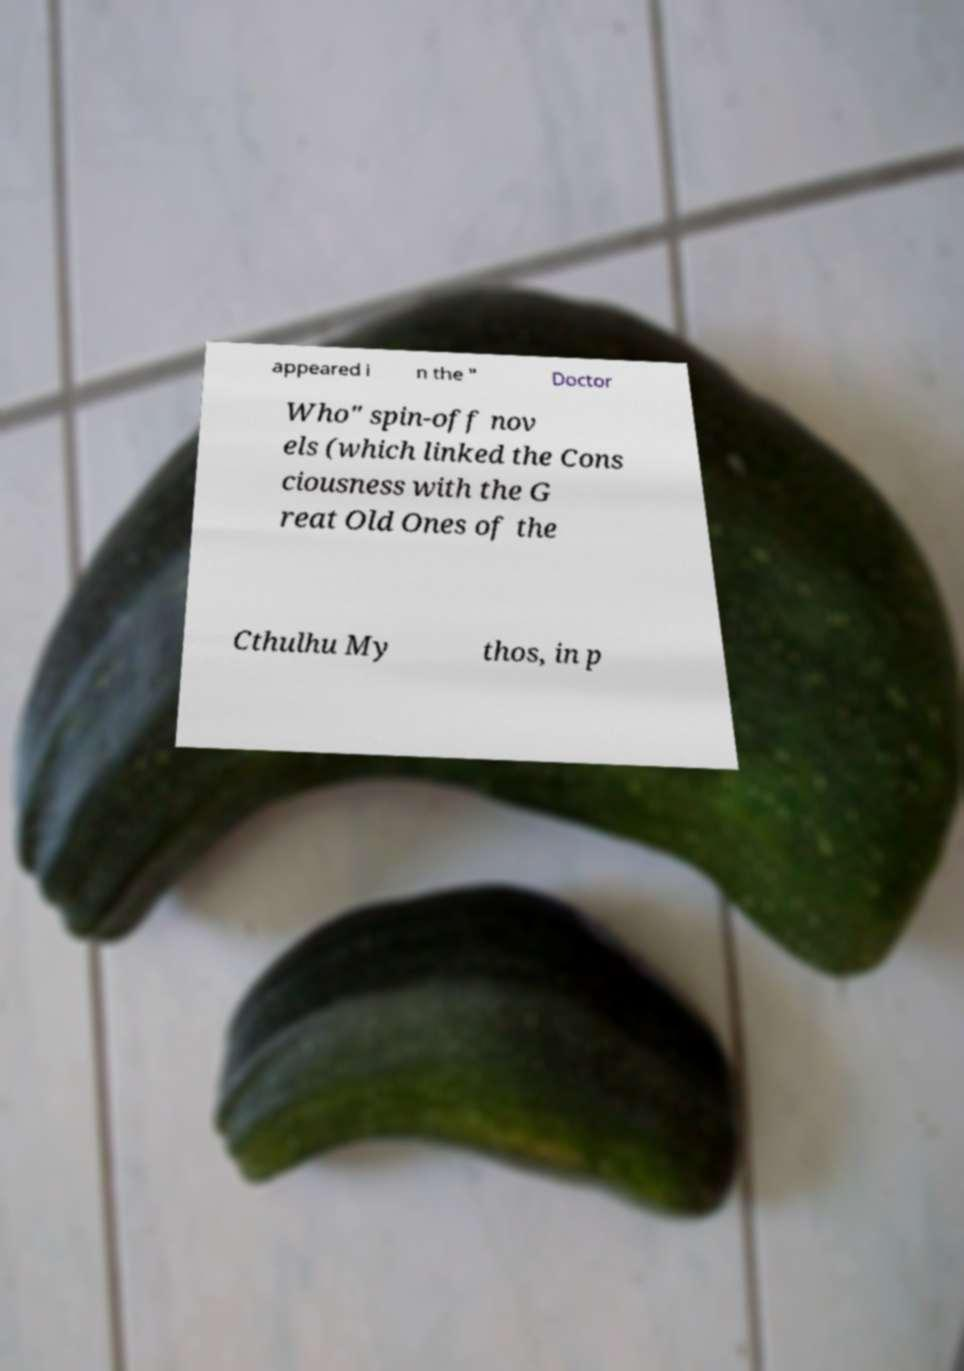Please identify and transcribe the text found in this image. appeared i n the " Doctor Who" spin-off nov els (which linked the Cons ciousness with the G reat Old Ones of the Cthulhu My thos, in p 